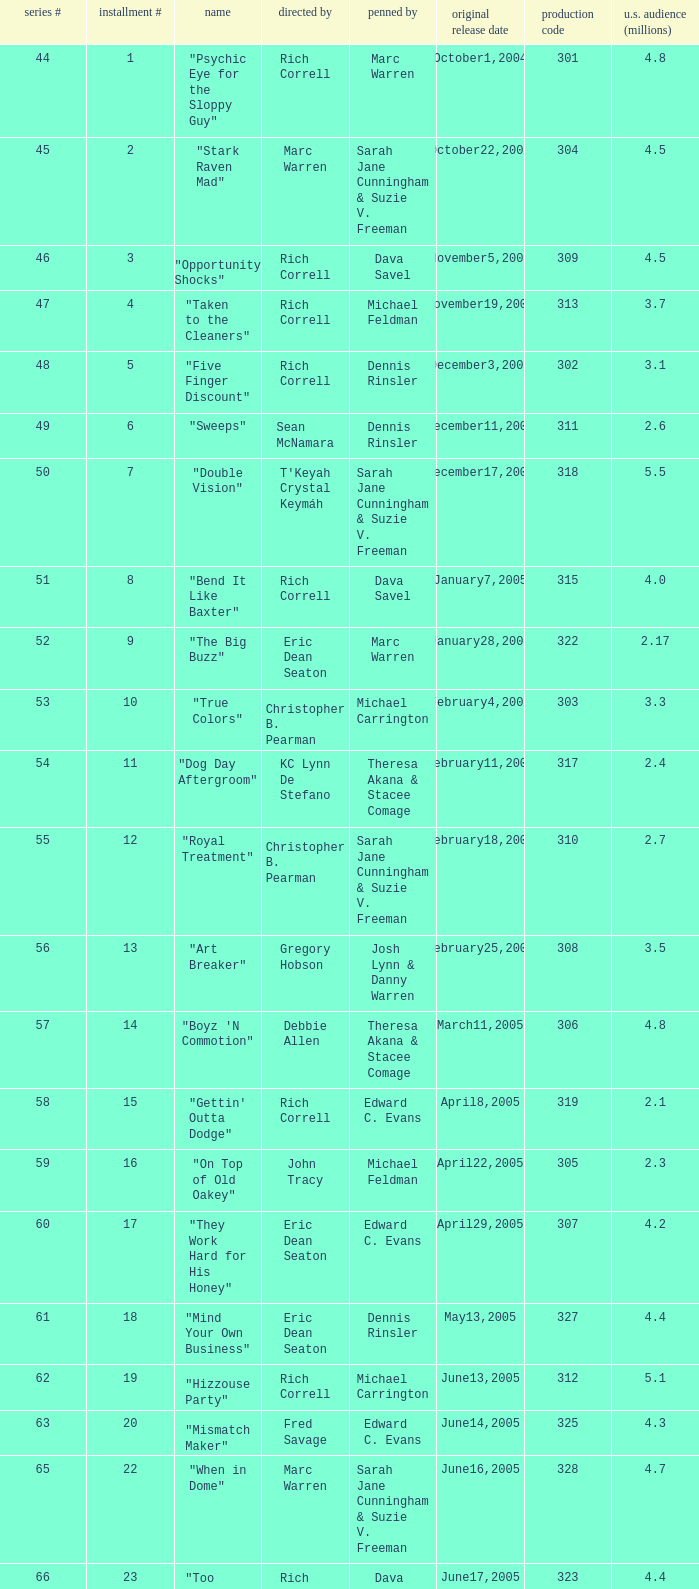What number episode in the season had a production code of 334? 32.0. Could you help me parse every detail presented in this table? {'header': ['series #', 'installment #', 'name', 'directed by', 'penned by', 'original release date', 'production code', 'u.s. audience (millions)'], 'rows': [['44', '1', '"Psychic Eye for the Sloppy Guy"', 'Rich Correll', 'Marc Warren', 'October1,2004', '301', '4.8'], ['45', '2', '"Stark Raven Mad"', 'Marc Warren', 'Sarah Jane Cunningham & Suzie V. Freeman', 'October22,2004', '304', '4.5'], ['46', '3', '"Opportunity Shocks"', 'Rich Correll', 'Dava Savel', 'November5,2004', '309', '4.5'], ['47', '4', '"Taken to the Cleaners"', 'Rich Correll', 'Michael Feldman', 'November19,2004', '313', '3.7'], ['48', '5', '"Five Finger Discount"', 'Rich Correll', 'Dennis Rinsler', 'December3,2004', '302', '3.1'], ['49', '6', '"Sweeps"', 'Sean McNamara', 'Dennis Rinsler', 'December11,2004', '311', '2.6'], ['50', '7', '"Double Vision"', "T'Keyah Crystal Keymáh", 'Sarah Jane Cunningham & Suzie V. Freeman', 'December17,2004', '318', '5.5'], ['51', '8', '"Bend It Like Baxter"', 'Rich Correll', 'Dava Savel', 'January7,2005', '315', '4.0'], ['52', '9', '"The Big Buzz"', 'Eric Dean Seaton', 'Marc Warren', 'January28,2005', '322', '2.17'], ['53', '10', '"True Colors"', 'Christopher B. Pearman', 'Michael Carrington', 'February4,2005', '303', '3.3'], ['54', '11', '"Dog Day Aftergroom"', 'KC Lynn De Stefano', 'Theresa Akana & Stacee Comage', 'February11,2005', '317', '2.4'], ['55', '12', '"Royal Treatment"', 'Christopher B. Pearman', 'Sarah Jane Cunningham & Suzie V. Freeman', 'February18,2005', '310', '2.7'], ['56', '13', '"Art Breaker"', 'Gregory Hobson', 'Josh Lynn & Danny Warren', 'February25,2005', '308', '3.5'], ['57', '14', '"Boyz \'N Commotion"', 'Debbie Allen', 'Theresa Akana & Stacee Comage', 'March11,2005', '306', '4.8'], ['58', '15', '"Gettin\' Outta Dodge"', 'Rich Correll', 'Edward C. Evans', 'April8,2005', '319', '2.1'], ['59', '16', '"On Top of Old Oakey"', 'John Tracy', 'Michael Feldman', 'April22,2005', '305', '2.3'], ['60', '17', '"They Work Hard for His Honey"', 'Eric Dean Seaton', 'Edward C. Evans', 'April29,2005', '307', '4.2'], ['61', '18', '"Mind Your Own Business"', 'Eric Dean Seaton', 'Dennis Rinsler', 'May13,2005', '327', '4.4'], ['62', '19', '"Hizzouse Party"', 'Rich Correll', 'Michael Carrington', 'June13,2005', '312', '5.1'], ['63', '20', '"Mismatch Maker"', 'Fred Savage', 'Edward C. Evans', 'June14,2005', '325', '4.3'], ['65', '22', '"When in Dome"', 'Marc Warren', 'Sarah Jane Cunningham & Suzie V. Freeman', 'June16,2005', '328', '4.7'], ['66', '23', '"Too Much Pressure"', 'Rich Correll', 'Dava Savel', 'June17,2005', '323', '4.4'], ['67', '24', '"Extreme Cory"', 'Rich Correll', 'Theresa Akana & Stacee Comage', 'July8,2005', '326', '3.8'], ['68', '25', '"The Grill Next Door"', 'Sean McNamara', 'Michael Feldman', 'July8,2005', '324', '4.23'], ['69', '26', '"Point of No Return"', 'Sean McNamara', 'Edward C. Evans', 'July23,2005', '330', '6.0'], ['72', '29', '"Food for Thought"', 'Rich Correll', 'Marc Warren', 'September18,2005', '316', '3.4'], ['73', '30', '"Mr. Perfect"', 'Rich Correll', 'Michael Carrington', 'October7,2005', '329', '3.0'], ['74', '31', '"Goin\' Hollywood"', 'Rich Correll', 'Dennis Rinsler & Marc Warren', 'November4,2005', '333', '3.7'], ['75', '32', '"Save the Last Dance"', 'Sean McNamara', 'Marc Warren', 'November25,2005', '334', '3.3'], ['76', '33', '"Cake Fear"', 'Rondell Sheridan', 'Theresa Akana & Stacee Comage', 'December16,2005', '332', '3.6'], ['77', '34', '"Vision Impossible"', 'Marc Warren', 'David Brookwell & Sean McNamara', 'January6,2006', '335', '4.7']]} 